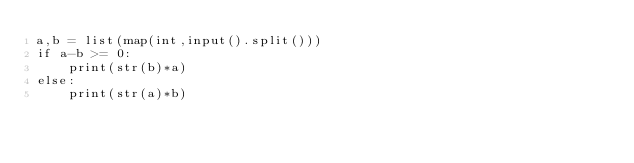Convert code to text. <code><loc_0><loc_0><loc_500><loc_500><_Python_>a,b = list(map(int,input().split()))
if a-b >= 0:
    print(str(b)*a)
else:
    print(str(a)*b)</code> 